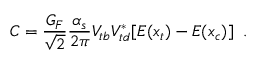<formula> <loc_0><loc_0><loc_500><loc_500>C = \frac { G _ { F } } { \sqrt { 2 } } \frac { \alpha _ { s } } { 2 \pi } V _ { t b } V _ { t d } ^ { * } [ E ( x _ { t } ) - E ( x _ { c } ) ] \, .</formula> 